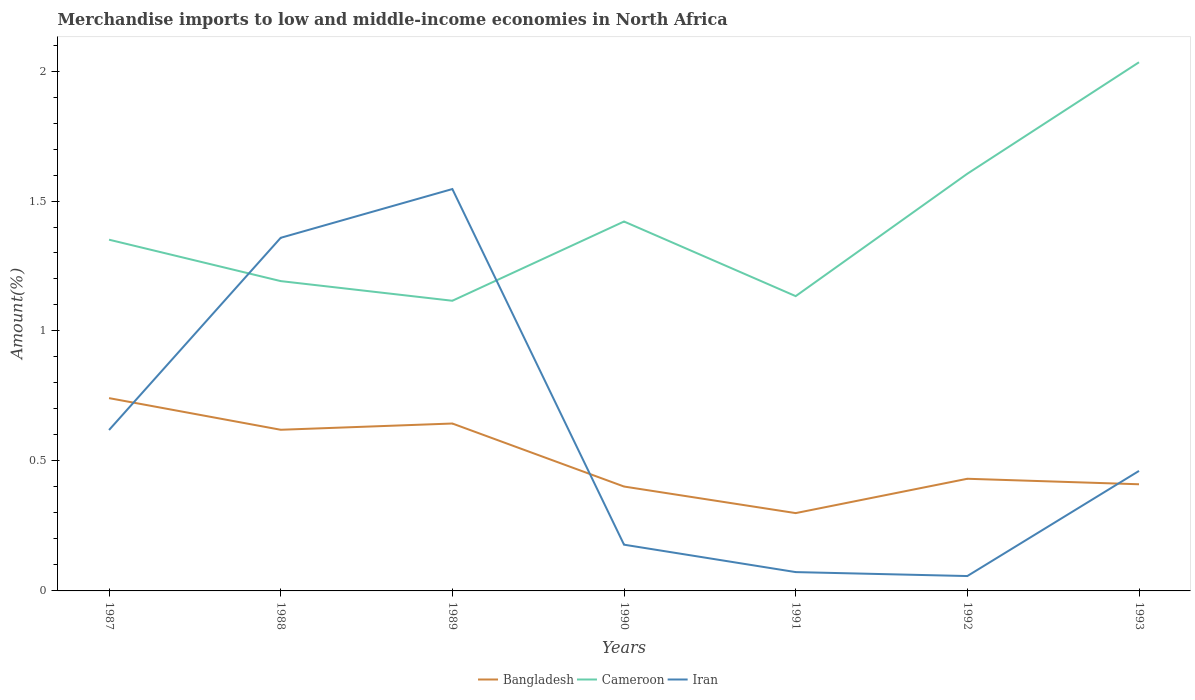How many different coloured lines are there?
Offer a very short reply. 3. Is the number of lines equal to the number of legend labels?
Keep it short and to the point. Yes. Across all years, what is the maximum percentage of amount earned from merchandise imports in Cameroon?
Your answer should be very brief. 1.12. What is the total percentage of amount earned from merchandise imports in Bangladesh in the graph?
Offer a terse response. 0.34. What is the difference between the highest and the second highest percentage of amount earned from merchandise imports in Iran?
Offer a terse response. 1.49. What is the difference between the highest and the lowest percentage of amount earned from merchandise imports in Cameroon?
Your answer should be very brief. 3. Is the percentage of amount earned from merchandise imports in Iran strictly greater than the percentage of amount earned from merchandise imports in Bangladesh over the years?
Provide a succinct answer. No. Are the values on the major ticks of Y-axis written in scientific E-notation?
Provide a short and direct response. No. Where does the legend appear in the graph?
Your response must be concise. Bottom center. How many legend labels are there?
Keep it short and to the point. 3. How are the legend labels stacked?
Your answer should be compact. Horizontal. What is the title of the graph?
Keep it short and to the point. Merchandise imports to low and middle-income economies in North Africa. Does "Estonia" appear as one of the legend labels in the graph?
Keep it short and to the point. No. What is the label or title of the X-axis?
Ensure brevity in your answer.  Years. What is the label or title of the Y-axis?
Give a very brief answer. Amount(%). What is the Amount(%) in Bangladesh in 1987?
Your answer should be very brief. 0.74. What is the Amount(%) in Cameroon in 1987?
Your answer should be compact. 1.35. What is the Amount(%) in Iran in 1987?
Your answer should be very brief. 0.62. What is the Amount(%) of Bangladesh in 1988?
Offer a very short reply. 0.62. What is the Amount(%) of Cameroon in 1988?
Keep it short and to the point. 1.19. What is the Amount(%) in Iran in 1988?
Offer a terse response. 1.36. What is the Amount(%) in Bangladesh in 1989?
Ensure brevity in your answer.  0.64. What is the Amount(%) of Cameroon in 1989?
Offer a terse response. 1.12. What is the Amount(%) in Iran in 1989?
Offer a very short reply. 1.55. What is the Amount(%) in Bangladesh in 1990?
Provide a short and direct response. 0.4. What is the Amount(%) in Cameroon in 1990?
Offer a very short reply. 1.42. What is the Amount(%) in Iran in 1990?
Make the answer very short. 0.18. What is the Amount(%) of Bangladesh in 1991?
Your answer should be very brief. 0.3. What is the Amount(%) in Cameroon in 1991?
Ensure brevity in your answer.  1.13. What is the Amount(%) in Iran in 1991?
Make the answer very short. 0.07. What is the Amount(%) in Bangladesh in 1992?
Keep it short and to the point. 0.43. What is the Amount(%) in Cameroon in 1992?
Ensure brevity in your answer.  1.6. What is the Amount(%) of Iran in 1992?
Your answer should be very brief. 0.06. What is the Amount(%) in Bangladesh in 1993?
Provide a short and direct response. 0.41. What is the Amount(%) of Cameroon in 1993?
Provide a short and direct response. 2.03. What is the Amount(%) in Iran in 1993?
Make the answer very short. 0.46. Across all years, what is the maximum Amount(%) in Bangladesh?
Keep it short and to the point. 0.74. Across all years, what is the maximum Amount(%) in Cameroon?
Keep it short and to the point. 2.03. Across all years, what is the maximum Amount(%) in Iran?
Keep it short and to the point. 1.55. Across all years, what is the minimum Amount(%) of Bangladesh?
Make the answer very short. 0.3. Across all years, what is the minimum Amount(%) in Cameroon?
Make the answer very short. 1.12. Across all years, what is the minimum Amount(%) of Iran?
Offer a terse response. 0.06. What is the total Amount(%) in Bangladesh in the graph?
Your answer should be very brief. 3.55. What is the total Amount(%) of Cameroon in the graph?
Your response must be concise. 9.85. What is the total Amount(%) in Iran in the graph?
Offer a very short reply. 4.29. What is the difference between the Amount(%) in Bangladesh in 1987 and that in 1988?
Give a very brief answer. 0.12. What is the difference between the Amount(%) of Cameroon in 1987 and that in 1988?
Your answer should be compact. 0.16. What is the difference between the Amount(%) in Iran in 1987 and that in 1988?
Your answer should be very brief. -0.74. What is the difference between the Amount(%) of Bangladesh in 1987 and that in 1989?
Provide a succinct answer. 0.1. What is the difference between the Amount(%) in Cameroon in 1987 and that in 1989?
Your answer should be compact. 0.23. What is the difference between the Amount(%) in Iran in 1987 and that in 1989?
Your answer should be compact. -0.93. What is the difference between the Amount(%) in Bangladesh in 1987 and that in 1990?
Your answer should be compact. 0.34. What is the difference between the Amount(%) in Cameroon in 1987 and that in 1990?
Your answer should be compact. -0.07. What is the difference between the Amount(%) in Iran in 1987 and that in 1990?
Your response must be concise. 0.44. What is the difference between the Amount(%) of Bangladesh in 1987 and that in 1991?
Give a very brief answer. 0.44. What is the difference between the Amount(%) in Cameroon in 1987 and that in 1991?
Keep it short and to the point. 0.22. What is the difference between the Amount(%) of Iran in 1987 and that in 1991?
Provide a short and direct response. 0.55. What is the difference between the Amount(%) in Bangladesh in 1987 and that in 1992?
Offer a terse response. 0.31. What is the difference between the Amount(%) in Cameroon in 1987 and that in 1992?
Your answer should be very brief. -0.25. What is the difference between the Amount(%) of Iran in 1987 and that in 1992?
Give a very brief answer. 0.56. What is the difference between the Amount(%) of Bangladesh in 1987 and that in 1993?
Make the answer very short. 0.33. What is the difference between the Amount(%) of Cameroon in 1987 and that in 1993?
Provide a succinct answer. -0.68. What is the difference between the Amount(%) in Iran in 1987 and that in 1993?
Keep it short and to the point. 0.16. What is the difference between the Amount(%) in Bangladesh in 1988 and that in 1989?
Offer a very short reply. -0.02. What is the difference between the Amount(%) of Cameroon in 1988 and that in 1989?
Your answer should be compact. 0.08. What is the difference between the Amount(%) of Iran in 1988 and that in 1989?
Give a very brief answer. -0.19. What is the difference between the Amount(%) in Bangladesh in 1988 and that in 1990?
Your answer should be very brief. 0.22. What is the difference between the Amount(%) in Cameroon in 1988 and that in 1990?
Your answer should be very brief. -0.23. What is the difference between the Amount(%) in Iran in 1988 and that in 1990?
Provide a succinct answer. 1.18. What is the difference between the Amount(%) in Bangladesh in 1988 and that in 1991?
Your response must be concise. 0.32. What is the difference between the Amount(%) of Cameroon in 1988 and that in 1991?
Provide a succinct answer. 0.06. What is the difference between the Amount(%) of Iran in 1988 and that in 1991?
Make the answer very short. 1.29. What is the difference between the Amount(%) in Bangladesh in 1988 and that in 1992?
Ensure brevity in your answer.  0.19. What is the difference between the Amount(%) of Cameroon in 1988 and that in 1992?
Offer a very short reply. -0.41. What is the difference between the Amount(%) of Iran in 1988 and that in 1992?
Provide a succinct answer. 1.3. What is the difference between the Amount(%) of Bangladesh in 1988 and that in 1993?
Ensure brevity in your answer.  0.21. What is the difference between the Amount(%) in Cameroon in 1988 and that in 1993?
Offer a terse response. -0.84. What is the difference between the Amount(%) of Iran in 1988 and that in 1993?
Give a very brief answer. 0.9. What is the difference between the Amount(%) in Bangladesh in 1989 and that in 1990?
Keep it short and to the point. 0.24. What is the difference between the Amount(%) of Cameroon in 1989 and that in 1990?
Make the answer very short. -0.3. What is the difference between the Amount(%) in Iran in 1989 and that in 1990?
Give a very brief answer. 1.37. What is the difference between the Amount(%) in Bangladesh in 1989 and that in 1991?
Ensure brevity in your answer.  0.34. What is the difference between the Amount(%) in Cameroon in 1989 and that in 1991?
Keep it short and to the point. -0.02. What is the difference between the Amount(%) of Iran in 1989 and that in 1991?
Offer a very short reply. 1.47. What is the difference between the Amount(%) of Bangladesh in 1989 and that in 1992?
Make the answer very short. 0.21. What is the difference between the Amount(%) of Cameroon in 1989 and that in 1992?
Your answer should be compact. -0.49. What is the difference between the Amount(%) of Iran in 1989 and that in 1992?
Your response must be concise. 1.49. What is the difference between the Amount(%) in Bangladesh in 1989 and that in 1993?
Ensure brevity in your answer.  0.23. What is the difference between the Amount(%) in Cameroon in 1989 and that in 1993?
Provide a succinct answer. -0.92. What is the difference between the Amount(%) of Iran in 1989 and that in 1993?
Offer a terse response. 1.08. What is the difference between the Amount(%) in Bangladesh in 1990 and that in 1991?
Keep it short and to the point. 0.1. What is the difference between the Amount(%) of Cameroon in 1990 and that in 1991?
Keep it short and to the point. 0.29. What is the difference between the Amount(%) of Iran in 1990 and that in 1991?
Offer a very short reply. 0.11. What is the difference between the Amount(%) of Bangladesh in 1990 and that in 1992?
Offer a very short reply. -0.03. What is the difference between the Amount(%) in Cameroon in 1990 and that in 1992?
Your response must be concise. -0.18. What is the difference between the Amount(%) in Iran in 1990 and that in 1992?
Your response must be concise. 0.12. What is the difference between the Amount(%) in Bangladesh in 1990 and that in 1993?
Your answer should be very brief. -0.01. What is the difference between the Amount(%) of Cameroon in 1990 and that in 1993?
Your response must be concise. -0.61. What is the difference between the Amount(%) in Iran in 1990 and that in 1993?
Make the answer very short. -0.28. What is the difference between the Amount(%) in Bangladesh in 1991 and that in 1992?
Offer a terse response. -0.13. What is the difference between the Amount(%) in Cameroon in 1991 and that in 1992?
Provide a short and direct response. -0.47. What is the difference between the Amount(%) of Iran in 1991 and that in 1992?
Offer a very short reply. 0.02. What is the difference between the Amount(%) of Bangladesh in 1991 and that in 1993?
Your answer should be very brief. -0.11. What is the difference between the Amount(%) in Cameroon in 1991 and that in 1993?
Give a very brief answer. -0.9. What is the difference between the Amount(%) in Iran in 1991 and that in 1993?
Offer a very short reply. -0.39. What is the difference between the Amount(%) in Bangladesh in 1992 and that in 1993?
Your answer should be very brief. 0.02. What is the difference between the Amount(%) in Cameroon in 1992 and that in 1993?
Offer a very short reply. -0.43. What is the difference between the Amount(%) in Iran in 1992 and that in 1993?
Keep it short and to the point. -0.4. What is the difference between the Amount(%) of Bangladesh in 1987 and the Amount(%) of Cameroon in 1988?
Provide a short and direct response. -0.45. What is the difference between the Amount(%) in Bangladesh in 1987 and the Amount(%) in Iran in 1988?
Offer a very short reply. -0.62. What is the difference between the Amount(%) of Cameroon in 1987 and the Amount(%) of Iran in 1988?
Make the answer very short. -0.01. What is the difference between the Amount(%) of Bangladesh in 1987 and the Amount(%) of Cameroon in 1989?
Give a very brief answer. -0.37. What is the difference between the Amount(%) of Bangladesh in 1987 and the Amount(%) of Iran in 1989?
Keep it short and to the point. -0.8. What is the difference between the Amount(%) in Cameroon in 1987 and the Amount(%) in Iran in 1989?
Give a very brief answer. -0.19. What is the difference between the Amount(%) of Bangladesh in 1987 and the Amount(%) of Cameroon in 1990?
Your response must be concise. -0.68. What is the difference between the Amount(%) of Bangladesh in 1987 and the Amount(%) of Iran in 1990?
Your response must be concise. 0.56. What is the difference between the Amount(%) in Cameroon in 1987 and the Amount(%) in Iran in 1990?
Offer a very short reply. 1.17. What is the difference between the Amount(%) in Bangladesh in 1987 and the Amount(%) in Cameroon in 1991?
Offer a terse response. -0.39. What is the difference between the Amount(%) in Bangladesh in 1987 and the Amount(%) in Iran in 1991?
Your answer should be very brief. 0.67. What is the difference between the Amount(%) of Cameroon in 1987 and the Amount(%) of Iran in 1991?
Make the answer very short. 1.28. What is the difference between the Amount(%) of Bangladesh in 1987 and the Amount(%) of Cameroon in 1992?
Provide a short and direct response. -0.86. What is the difference between the Amount(%) in Bangladesh in 1987 and the Amount(%) in Iran in 1992?
Offer a terse response. 0.68. What is the difference between the Amount(%) in Cameroon in 1987 and the Amount(%) in Iran in 1992?
Provide a short and direct response. 1.29. What is the difference between the Amount(%) of Bangladesh in 1987 and the Amount(%) of Cameroon in 1993?
Offer a terse response. -1.29. What is the difference between the Amount(%) of Bangladesh in 1987 and the Amount(%) of Iran in 1993?
Your response must be concise. 0.28. What is the difference between the Amount(%) of Cameroon in 1987 and the Amount(%) of Iran in 1993?
Keep it short and to the point. 0.89. What is the difference between the Amount(%) in Bangladesh in 1988 and the Amount(%) in Cameroon in 1989?
Keep it short and to the point. -0.5. What is the difference between the Amount(%) in Bangladesh in 1988 and the Amount(%) in Iran in 1989?
Ensure brevity in your answer.  -0.93. What is the difference between the Amount(%) of Cameroon in 1988 and the Amount(%) of Iran in 1989?
Make the answer very short. -0.35. What is the difference between the Amount(%) of Bangladesh in 1988 and the Amount(%) of Cameroon in 1990?
Your answer should be very brief. -0.8. What is the difference between the Amount(%) in Bangladesh in 1988 and the Amount(%) in Iran in 1990?
Give a very brief answer. 0.44. What is the difference between the Amount(%) in Cameroon in 1988 and the Amount(%) in Iran in 1990?
Give a very brief answer. 1.01. What is the difference between the Amount(%) of Bangladesh in 1988 and the Amount(%) of Cameroon in 1991?
Your answer should be compact. -0.51. What is the difference between the Amount(%) of Bangladesh in 1988 and the Amount(%) of Iran in 1991?
Your response must be concise. 0.55. What is the difference between the Amount(%) in Cameroon in 1988 and the Amount(%) in Iran in 1991?
Ensure brevity in your answer.  1.12. What is the difference between the Amount(%) of Bangladesh in 1988 and the Amount(%) of Cameroon in 1992?
Your answer should be compact. -0.98. What is the difference between the Amount(%) in Bangladesh in 1988 and the Amount(%) in Iran in 1992?
Make the answer very short. 0.56. What is the difference between the Amount(%) of Cameroon in 1988 and the Amount(%) of Iran in 1992?
Give a very brief answer. 1.13. What is the difference between the Amount(%) in Bangladesh in 1988 and the Amount(%) in Cameroon in 1993?
Your answer should be compact. -1.41. What is the difference between the Amount(%) of Bangladesh in 1988 and the Amount(%) of Iran in 1993?
Your answer should be compact. 0.16. What is the difference between the Amount(%) in Cameroon in 1988 and the Amount(%) in Iran in 1993?
Provide a short and direct response. 0.73. What is the difference between the Amount(%) of Bangladesh in 1989 and the Amount(%) of Cameroon in 1990?
Your response must be concise. -0.78. What is the difference between the Amount(%) in Bangladesh in 1989 and the Amount(%) in Iran in 1990?
Keep it short and to the point. 0.47. What is the difference between the Amount(%) in Cameroon in 1989 and the Amount(%) in Iran in 1990?
Offer a terse response. 0.94. What is the difference between the Amount(%) of Bangladesh in 1989 and the Amount(%) of Cameroon in 1991?
Keep it short and to the point. -0.49. What is the difference between the Amount(%) in Bangladesh in 1989 and the Amount(%) in Iran in 1991?
Your answer should be very brief. 0.57. What is the difference between the Amount(%) in Cameroon in 1989 and the Amount(%) in Iran in 1991?
Offer a very short reply. 1.04. What is the difference between the Amount(%) of Bangladesh in 1989 and the Amount(%) of Cameroon in 1992?
Your answer should be compact. -0.96. What is the difference between the Amount(%) of Bangladesh in 1989 and the Amount(%) of Iran in 1992?
Give a very brief answer. 0.59. What is the difference between the Amount(%) of Cameroon in 1989 and the Amount(%) of Iran in 1992?
Provide a succinct answer. 1.06. What is the difference between the Amount(%) of Bangladesh in 1989 and the Amount(%) of Cameroon in 1993?
Ensure brevity in your answer.  -1.39. What is the difference between the Amount(%) in Bangladesh in 1989 and the Amount(%) in Iran in 1993?
Your response must be concise. 0.18. What is the difference between the Amount(%) of Cameroon in 1989 and the Amount(%) of Iran in 1993?
Give a very brief answer. 0.65. What is the difference between the Amount(%) in Bangladesh in 1990 and the Amount(%) in Cameroon in 1991?
Your answer should be very brief. -0.73. What is the difference between the Amount(%) of Bangladesh in 1990 and the Amount(%) of Iran in 1991?
Keep it short and to the point. 0.33. What is the difference between the Amount(%) in Cameroon in 1990 and the Amount(%) in Iran in 1991?
Your response must be concise. 1.35. What is the difference between the Amount(%) of Bangladesh in 1990 and the Amount(%) of Cameroon in 1992?
Your answer should be very brief. -1.2. What is the difference between the Amount(%) in Bangladesh in 1990 and the Amount(%) in Iran in 1992?
Offer a very short reply. 0.34. What is the difference between the Amount(%) in Cameroon in 1990 and the Amount(%) in Iran in 1992?
Your response must be concise. 1.36. What is the difference between the Amount(%) in Bangladesh in 1990 and the Amount(%) in Cameroon in 1993?
Offer a very short reply. -1.63. What is the difference between the Amount(%) in Bangladesh in 1990 and the Amount(%) in Iran in 1993?
Keep it short and to the point. -0.06. What is the difference between the Amount(%) of Cameroon in 1990 and the Amount(%) of Iran in 1993?
Offer a terse response. 0.96. What is the difference between the Amount(%) of Bangladesh in 1991 and the Amount(%) of Cameroon in 1992?
Your answer should be very brief. -1.31. What is the difference between the Amount(%) in Bangladesh in 1991 and the Amount(%) in Iran in 1992?
Your answer should be compact. 0.24. What is the difference between the Amount(%) of Cameroon in 1991 and the Amount(%) of Iran in 1992?
Keep it short and to the point. 1.08. What is the difference between the Amount(%) of Bangladesh in 1991 and the Amount(%) of Cameroon in 1993?
Your response must be concise. -1.73. What is the difference between the Amount(%) in Bangladesh in 1991 and the Amount(%) in Iran in 1993?
Ensure brevity in your answer.  -0.16. What is the difference between the Amount(%) of Cameroon in 1991 and the Amount(%) of Iran in 1993?
Offer a very short reply. 0.67. What is the difference between the Amount(%) of Bangladesh in 1992 and the Amount(%) of Cameroon in 1993?
Provide a short and direct response. -1.6. What is the difference between the Amount(%) in Bangladesh in 1992 and the Amount(%) in Iran in 1993?
Provide a short and direct response. -0.03. What is the difference between the Amount(%) of Cameroon in 1992 and the Amount(%) of Iran in 1993?
Keep it short and to the point. 1.14. What is the average Amount(%) of Bangladesh per year?
Offer a terse response. 0.51. What is the average Amount(%) in Cameroon per year?
Keep it short and to the point. 1.41. What is the average Amount(%) in Iran per year?
Your response must be concise. 0.61. In the year 1987, what is the difference between the Amount(%) of Bangladesh and Amount(%) of Cameroon?
Provide a short and direct response. -0.61. In the year 1987, what is the difference between the Amount(%) in Bangladesh and Amount(%) in Iran?
Your answer should be compact. 0.12. In the year 1987, what is the difference between the Amount(%) of Cameroon and Amount(%) of Iran?
Provide a short and direct response. 0.73. In the year 1988, what is the difference between the Amount(%) of Bangladesh and Amount(%) of Cameroon?
Ensure brevity in your answer.  -0.57. In the year 1988, what is the difference between the Amount(%) in Bangladesh and Amount(%) in Iran?
Offer a very short reply. -0.74. In the year 1988, what is the difference between the Amount(%) of Cameroon and Amount(%) of Iran?
Offer a terse response. -0.17. In the year 1989, what is the difference between the Amount(%) of Bangladesh and Amount(%) of Cameroon?
Give a very brief answer. -0.47. In the year 1989, what is the difference between the Amount(%) of Bangladesh and Amount(%) of Iran?
Offer a very short reply. -0.9. In the year 1989, what is the difference between the Amount(%) in Cameroon and Amount(%) in Iran?
Provide a succinct answer. -0.43. In the year 1990, what is the difference between the Amount(%) of Bangladesh and Amount(%) of Cameroon?
Ensure brevity in your answer.  -1.02. In the year 1990, what is the difference between the Amount(%) in Bangladesh and Amount(%) in Iran?
Keep it short and to the point. 0.22. In the year 1990, what is the difference between the Amount(%) in Cameroon and Amount(%) in Iran?
Ensure brevity in your answer.  1.24. In the year 1991, what is the difference between the Amount(%) in Bangladesh and Amount(%) in Cameroon?
Give a very brief answer. -0.83. In the year 1991, what is the difference between the Amount(%) of Bangladesh and Amount(%) of Iran?
Ensure brevity in your answer.  0.23. In the year 1991, what is the difference between the Amount(%) in Cameroon and Amount(%) in Iran?
Give a very brief answer. 1.06. In the year 1992, what is the difference between the Amount(%) in Bangladesh and Amount(%) in Cameroon?
Give a very brief answer. -1.17. In the year 1992, what is the difference between the Amount(%) in Bangladesh and Amount(%) in Iran?
Ensure brevity in your answer.  0.37. In the year 1992, what is the difference between the Amount(%) of Cameroon and Amount(%) of Iran?
Make the answer very short. 1.55. In the year 1993, what is the difference between the Amount(%) in Bangladesh and Amount(%) in Cameroon?
Your response must be concise. -1.62. In the year 1993, what is the difference between the Amount(%) of Bangladesh and Amount(%) of Iran?
Keep it short and to the point. -0.05. In the year 1993, what is the difference between the Amount(%) in Cameroon and Amount(%) in Iran?
Offer a terse response. 1.57. What is the ratio of the Amount(%) of Bangladesh in 1987 to that in 1988?
Offer a very short reply. 1.2. What is the ratio of the Amount(%) of Cameroon in 1987 to that in 1988?
Provide a short and direct response. 1.13. What is the ratio of the Amount(%) of Iran in 1987 to that in 1988?
Provide a succinct answer. 0.46. What is the ratio of the Amount(%) in Bangladesh in 1987 to that in 1989?
Provide a short and direct response. 1.15. What is the ratio of the Amount(%) of Cameroon in 1987 to that in 1989?
Give a very brief answer. 1.21. What is the ratio of the Amount(%) of Iran in 1987 to that in 1989?
Your response must be concise. 0.4. What is the ratio of the Amount(%) in Bangladesh in 1987 to that in 1990?
Give a very brief answer. 1.85. What is the ratio of the Amount(%) in Cameroon in 1987 to that in 1990?
Offer a terse response. 0.95. What is the ratio of the Amount(%) of Iran in 1987 to that in 1990?
Your answer should be very brief. 3.48. What is the ratio of the Amount(%) in Bangladesh in 1987 to that in 1991?
Your answer should be very brief. 2.48. What is the ratio of the Amount(%) of Cameroon in 1987 to that in 1991?
Your response must be concise. 1.19. What is the ratio of the Amount(%) in Iran in 1987 to that in 1991?
Give a very brief answer. 8.55. What is the ratio of the Amount(%) of Bangladesh in 1987 to that in 1992?
Provide a succinct answer. 1.72. What is the ratio of the Amount(%) in Cameroon in 1987 to that in 1992?
Your answer should be compact. 0.84. What is the ratio of the Amount(%) of Iran in 1987 to that in 1992?
Keep it short and to the point. 10.81. What is the ratio of the Amount(%) of Bangladesh in 1987 to that in 1993?
Provide a short and direct response. 1.81. What is the ratio of the Amount(%) of Cameroon in 1987 to that in 1993?
Keep it short and to the point. 0.66. What is the ratio of the Amount(%) in Iran in 1987 to that in 1993?
Your response must be concise. 1.34. What is the ratio of the Amount(%) in Bangladesh in 1988 to that in 1989?
Make the answer very short. 0.96. What is the ratio of the Amount(%) of Cameroon in 1988 to that in 1989?
Provide a succinct answer. 1.07. What is the ratio of the Amount(%) of Iran in 1988 to that in 1989?
Your answer should be very brief. 0.88. What is the ratio of the Amount(%) in Bangladesh in 1988 to that in 1990?
Offer a very short reply. 1.54. What is the ratio of the Amount(%) of Cameroon in 1988 to that in 1990?
Your answer should be very brief. 0.84. What is the ratio of the Amount(%) in Iran in 1988 to that in 1990?
Keep it short and to the point. 7.64. What is the ratio of the Amount(%) of Bangladesh in 1988 to that in 1991?
Offer a very short reply. 2.07. What is the ratio of the Amount(%) of Cameroon in 1988 to that in 1991?
Your answer should be compact. 1.05. What is the ratio of the Amount(%) of Iran in 1988 to that in 1991?
Keep it short and to the point. 18.75. What is the ratio of the Amount(%) of Bangladesh in 1988 to that in 1992?
Offer a terse response. 1.44. What is the ratio of the Amount(%) of Cameroon in 1988 to that in 1992?
Your response must be concise. 0.74. What is the ratio of the Amount(%) in Iran in 1988 to that in 1992?
Offer a very short reply. 23.73. What is the ratio of the Amount(%) of Bangladesh in 1988 to that in 1993?
Provide a short and direct response. 1.51. What is the ratio of the Amount(%) in Cameroon in 1988 to that in 1993?
Make the answer very short. 0.59. What is the ratio of the Amount(%) of Iran in 1988 to that in 1993?
Your answer should be very brief. 2.94. What is the ratio of the Amount(%) of Bangladesh in 1989 to that in 1990?
Offer a terse response. 1.6. What is the ratio of the Amount(%) in Cameroon in 1989 to that in 1990?
Your answer should be very brief. 0.79. What is the ratio of the Amount(%) in Iran in 1989 to that in 1990?
Keep it short and to the point. 8.69. What is the ratio of the Amount(%) of Bangladesh in 1989 to that in 1991?
Keep it short and to the point. 2.15. What is the ratio of the Amount(%) in Cameroon in 1989 to that in 1991?
Make the answer very short. 0.98. What is the ratio of the Amount(%) of Iran in 1989 to that in 1991?
Provide a succinct answer. 21.34. What is the ratio of the Amount(%) of Bangladesh in 1989 to that in 1992?
Keep it short and to the point. 1.49. What is the ratio of the Amount(%) of Cameroon in 1989 to that in 1992?
Your answer should be compact. 0.7. What is the ratio of the Amount(%) of Iran in 1989 to that in 1992?
Your answer should be very brief. 27.01. What is the ratio of the Amount(%) of Bangladesh in 1989 to that in 1993?
Provide a short and direct response. 1.57. What is the ratio of the Amount(%) of Cameroon in 1989 to that in 1993?
Your response must be concise. 0.55. What is the ratio of the Amount(%) of Iran in 1989 to that in 1993?
Your response must be concise. 3.35. What is the ratio of the Amount(%) in Bangladesh in 1990 to that in 1991?
Ensure brevity in your answer.  1.34. What is the ratio of the Amount(%) in Cameroon in 1990 to that in 1991?
Ensure brevity in your answer.  1.25. What is the ratio of the Amount(%) of Iran in 1990 to that in 1991?
Ensure brevity in your answer.  2.46. What is the ratio of the Amount(%) of Bangladesh in 1990 to that in 1992?
Your response must be concise. 0.93. What is the ratio of the Amount(%) of Cameroon in 1990 to that in 1992?
Offer a very short reply. 0.89. What is the ratio of the Amount(%) of Iran in 1990 to that in 1992?
Offer a terse response. 3.11. What is the ratio of the Amount(%) of Bangladesh in 1990 to that in 1993?
Provide a short and direct response. 0.98. What is the ratio of the Amount(%) in Cameroon in 1990 to that in 1993?
Your answer should be compact. 0.7. What is the ratio of the Amount(%) in Iran in 1990 to that in 1993?
Your answer should be very brief. 0.39. What is the ratio of the Amount(%) in Bangladesh in 1991 to that in 1992?
Give a very brief answer. 0.69. What is the ratio of the Amount(%) of Cameroon in 1991 to that in 1992?
Provide a succinct answer. 0.71. What is the ratio of the Amount(%) of Iran in 1991 to that in 1992?
Give a very brief answer. 1.27. What is the ratio of the Amount(%) in Bangladesh in 1991 to that in 1993?
Provide a short and direct response. 0.73. What is the ratio of the Amount(%) in Cameroon in 1991 to that in 1993?
Offer a terse response. 0.56. What is the ratio of the Amount(%) in Iran in 1991 to that in 1993?
Provide a short and direct response. 0.16. What is the ratio of the Amount(%) of Bangladesh in 1992 to that in 1993?
Provide a short and direct response. 1.05. What is the ratio of the Amount(%) in Cameroon in 1992 to that in 1993?
Your response must be concise. 0.79. What is the ratio of the Amount(%) of Iran in 1992 to that in 1993?
Your answer should be very brief. 0.12. What is the difference between the highest and the second highest Amount(%) of Bangladesh?
Your response must be concise. 0.1. What is the difference between the highest and the second highest Amount(%) in Cameroon?
Offer a terse response. 0.43. What is the difference between the highest and the second highest Amount(%) of Iran?
Offer a terse response. 0.19. What is the difference between the highest and the lowest Amount(%) in Bangladesh?
Give a very brief answer. 0.44. What is the difference between the highest and the lowest Amount(%) in Cameroon?
Provide a succinct answer. 0.92. What is the difference between the highest and the lowest Amount(%) of Iran?
Give a very brief answer. 1.49. 